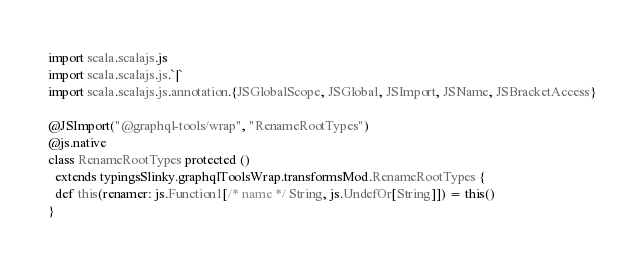<code> <loc_0><loc_0><loc_500><loc_500><_Scala_>
import scala.scalajs.js
import scala.scalajs.js.`|`
import scala.scalajs.js.annotation.{JSGlobalScope, JSGlobal, JSImport, JSName, JSBracketAccess}

@JSImport("@graphql-tools/wrap", "RenameRootTypes")
@js.native
class RenameRootTypes protected ()
  extends typingsSlinky.graphqlToolsWrap.transformsMod.RenameRootTypes {
  def this(renamer: js.Function1[/* name */ String, js.UndefOr[String]]) = this()
}
</code> 